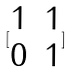Convert formula to latex. <formula><loc_0><loc_0><loc_500><loc_500>[ \begin{matrix} 1 & 1 \\ 0 & 1 \end{matrix} ]</formula> 